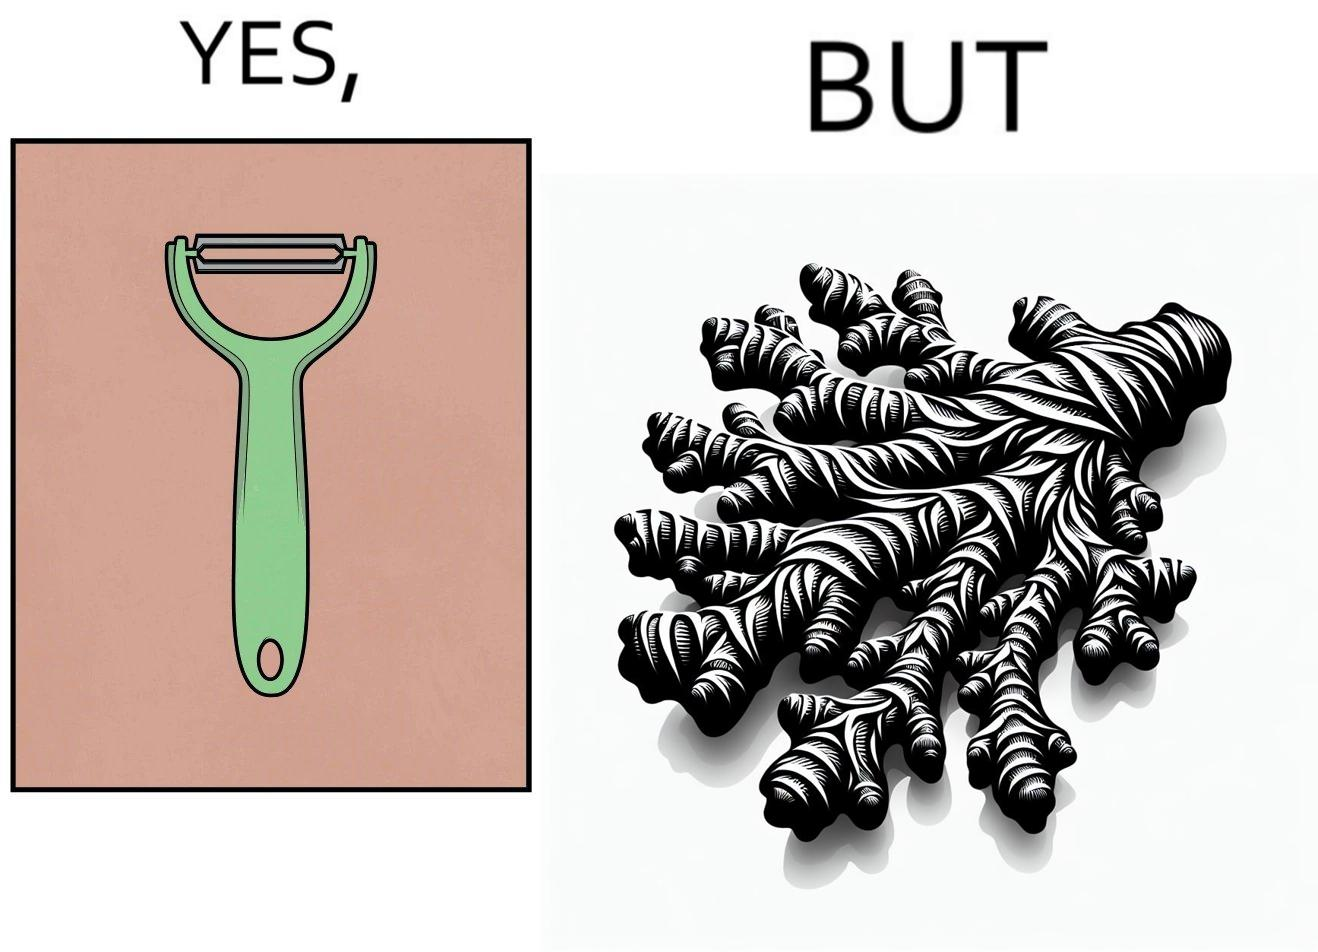Is there satirical content in this image? Yes, this image is satirical. 